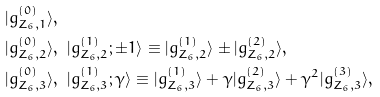<formula> <loc_0><loc_0><loc_500><loc_500>& | g ^ { ( 0 ) } _ { Z _ { 6 } , 1 } \rangle , \\ & | g ^ { ( 0 ) } _ { Z _ { 6 } , 2 } \rangle , \ | g ^ { ( 1 ) } _ { Z _ { 6 } , 2 } ; \pm 1 \rangle \equiv | g ^ { ( 1 ) } _ { Z _ { 6 } , 2 } \rangle \pm | g ^ { ( 2 ) } _ { Z _ { 6 } , 2 } \rangle , \\ & | g ^ { ( 0 ) } _ { Z _ { 6 } , 3 } \rangle , \ | g ^ { ( 1 ) } _ { Z _ { 6 } , 3 } ; \gamma \rangle \equiv | g ^ { ( 1 ) } _ { Z _ { 6 } , 3 } \rangle + \gamma | g ^ { ( 2 ) } _ { Z _ { 6 } , 3 } \rangle + \gamma ^ { 2 } | g ^ { ( 3 ) } _ { Z _ { 6 } , 3 } \rangle ,</formula> 